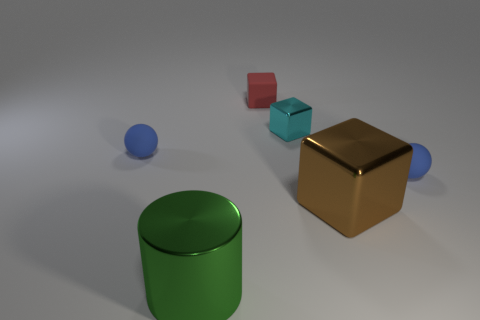What material is the tiny cyan block that is behind the blue ball on the left side of the small matte sphere that is right of the big brown object?
Provide a succinct answer. Metal. There is a tiny blue thing that is left of the small red object; does it have the same shape as the blue matte object right of the brown object?
Provide a succinct answer. Yes. The matte sphere that is in front of the blue matte ball that is on the left side of the brown shiny object is what color?
Give a very brief answer. Blue. How many blocks are either cyan objects or brown objects?
Your answer should be compact. 2. There is a small blue rubber ball that is behind the tiny rubber object that is to the right of the brown shiny block; how many shiny cylinders are behind it?
Your response must be concise. 0. Are there any cyan blocks made of the same material as the tiny red cube?
Make the answer very short. No. Does the big green cylinder have the same material as the small red object?
Ensure brevity in your answer.  No. There is a ball that is on the right side of the red rubber cube; how many tiny cyan metal objects are on the left side of it?
Your response must be concise. 1. How many blue things are either tiny rubber balls or metallic cylinders?
Your response must be concise. 2. What shape is the small matte object that is behind the tiny blue ball to the left of the sphere that is on the right side of the large green cylinder?
Provide a short and direct response. Cube. 